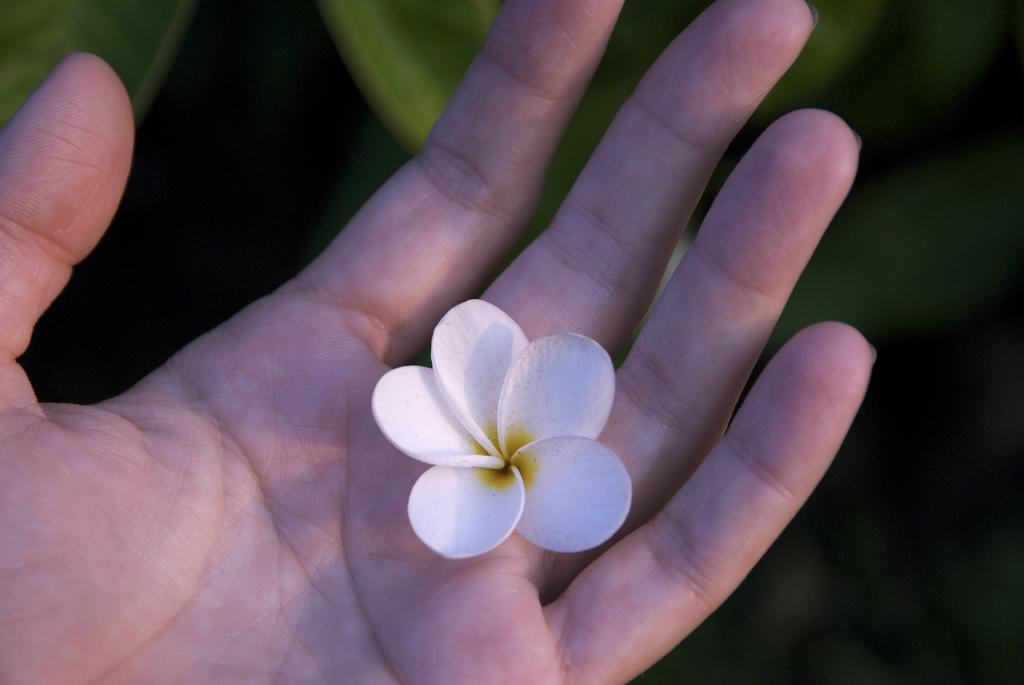Describe this image in one or two sentences. Background portion of the picture is blur and green leaves are visible. In this picture we can see a person's hand and a flower. 